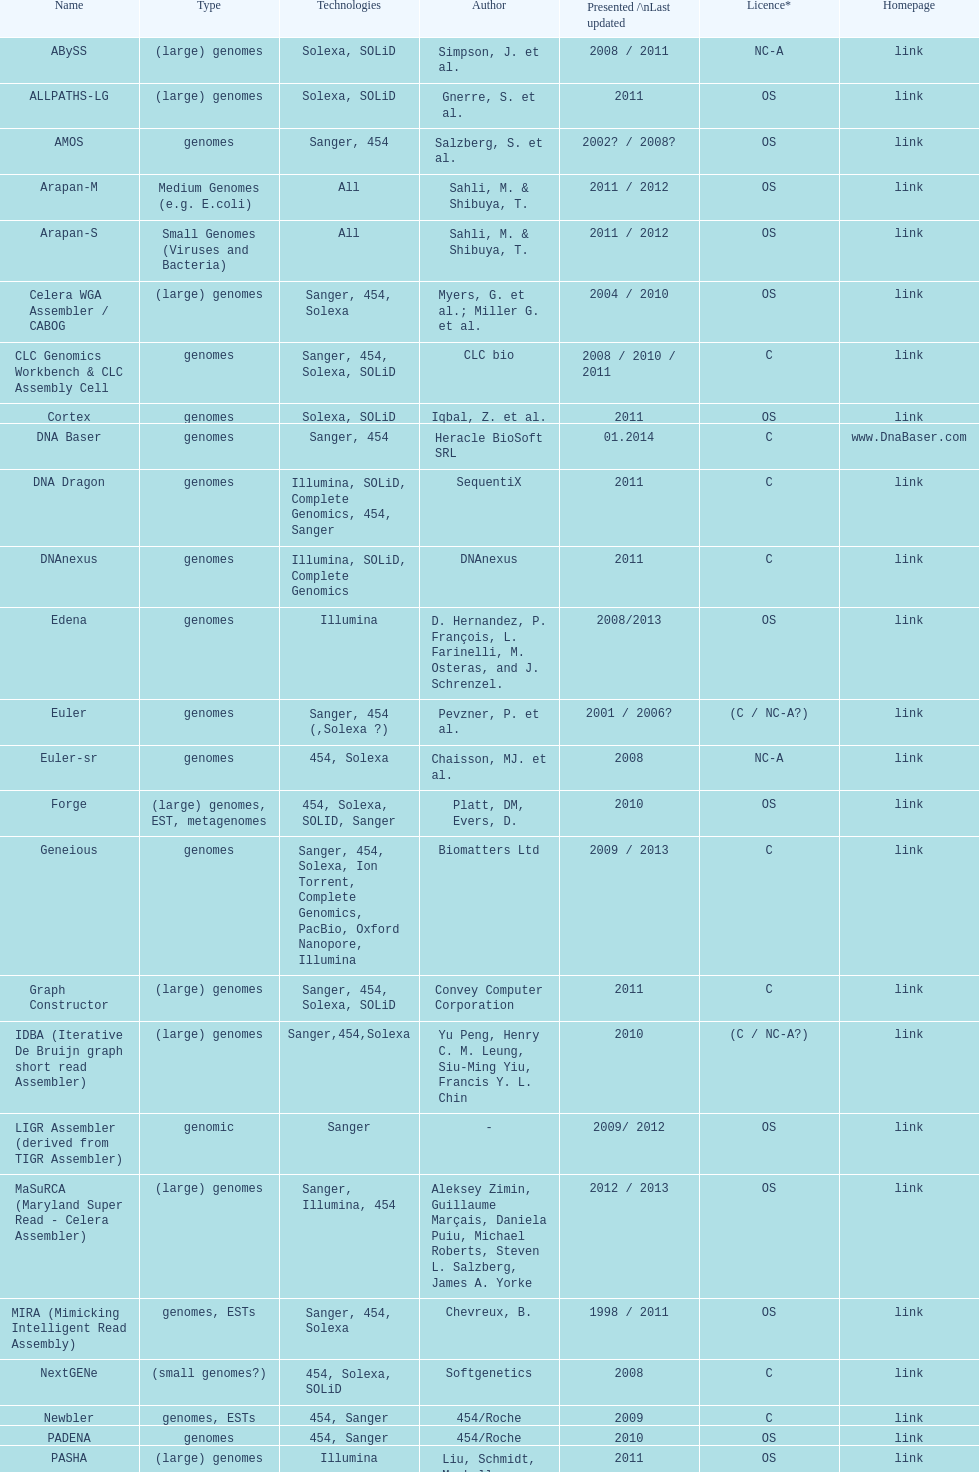When was the most recent update to the velvet? 2009. 